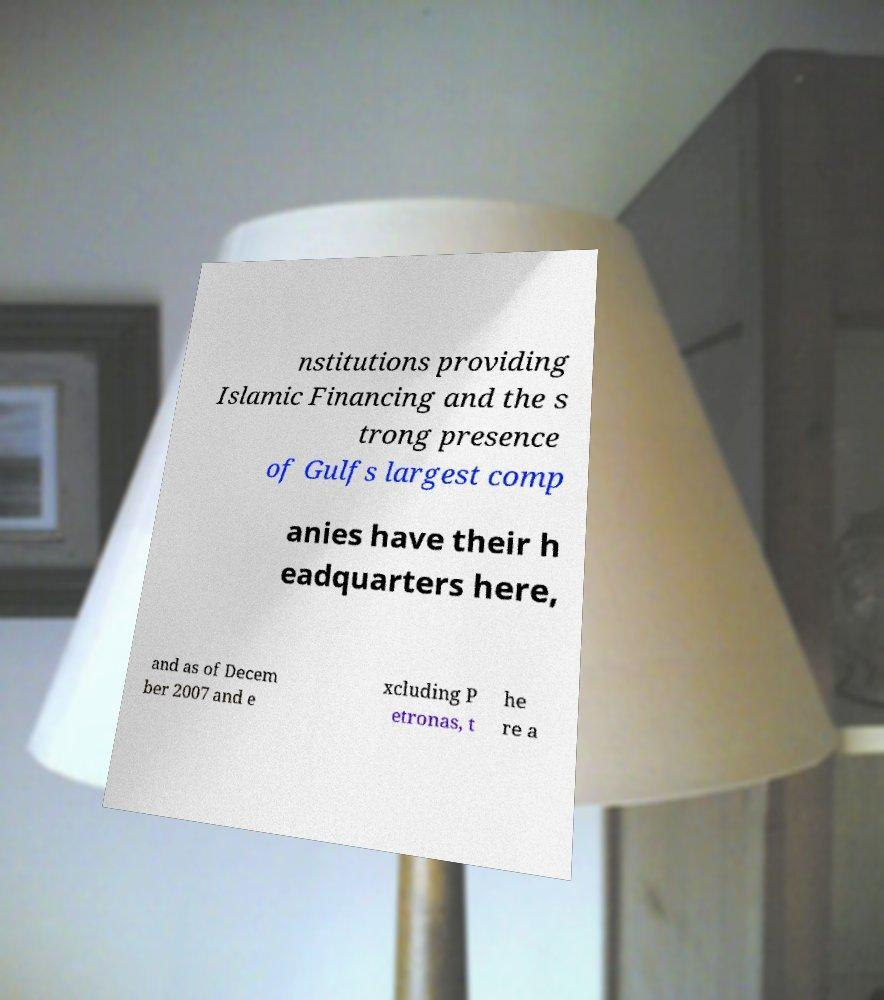I need the written content from this picture converted into text. Can you do that? nstitutions providing Islamic Financing and the s trong presence of Gulfs largest comp anies have their h eadquarters here, and as of Decem ber 2007 and e xcluding P etronas, t he re a 